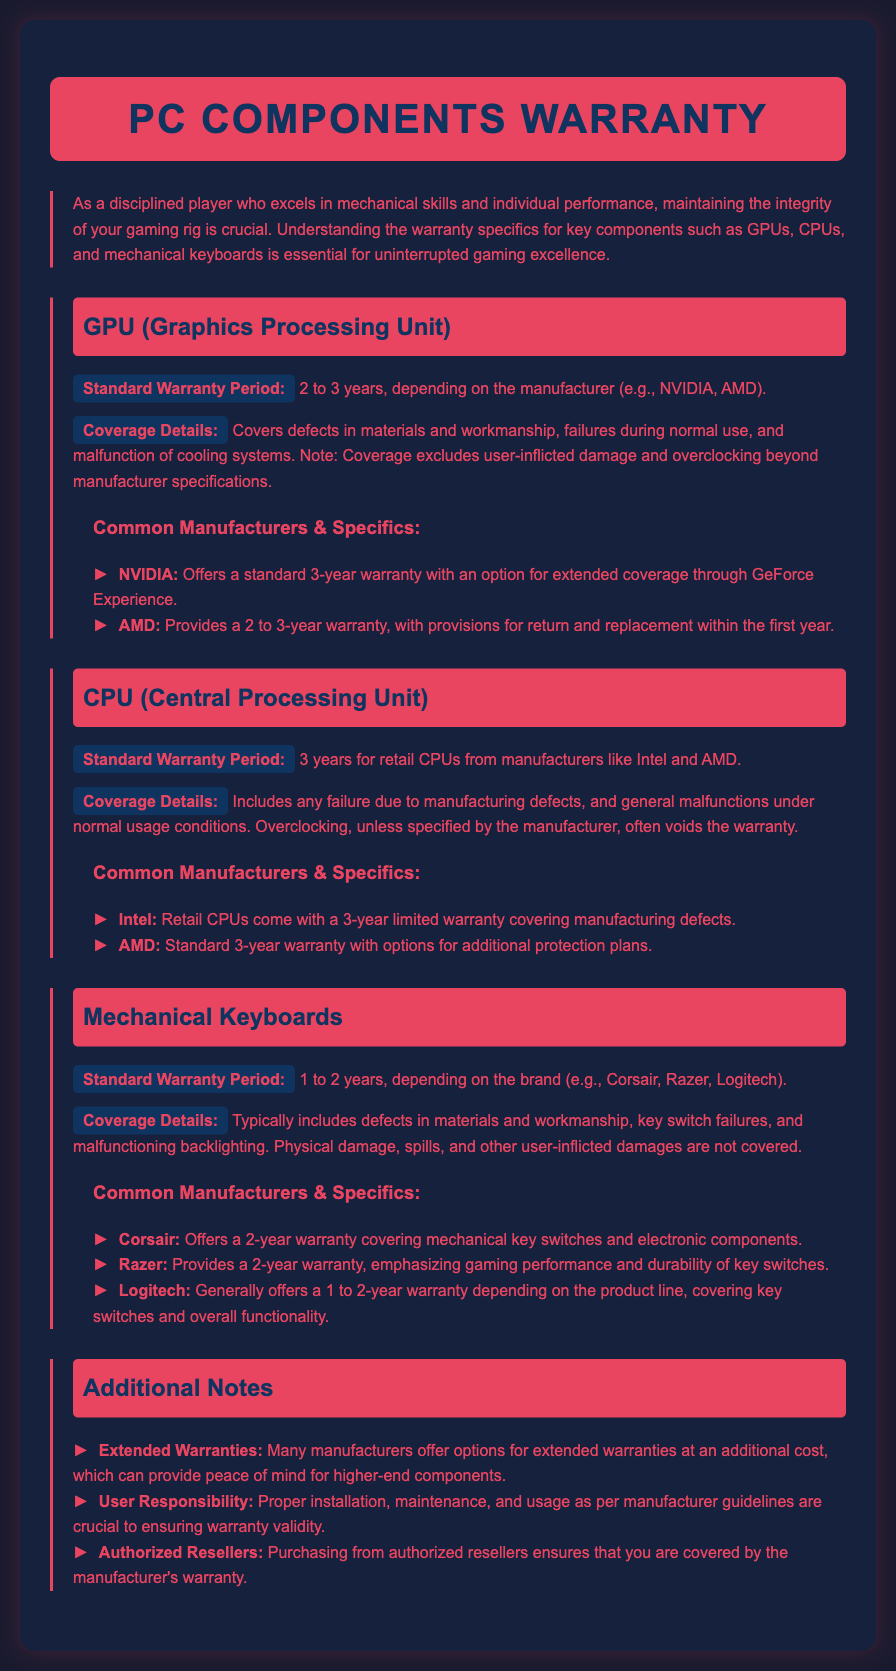What is the standard warranty period for GPUs? The document states that the standard warranty period for GPUs is 2 to 3 years, depending on the manufacturer.
Answer: 2 to 3 years What does GPU coverage exclude? The document mentions that GPU coverage excludes user-inflicted damage and overclocking beyond manufacturer specifications.
Answer: User-inflicted damage and overclocking What is the general warranty period for CPUs? It is stated in the document that retail CPUs have a standard warranty period of 3 years.
Answer: 3 years Which companies provide a 3-year warranty for CPUs? The document specifies that Intel and AMD provide a 3-year limited warranty for their retail CPUs.
Answer: Intel and AMD What is the warranty period for Corsair mechanical keyboards? The document indicates that Corsair offers a 2-year warranty for mechanical keyboards.
Answer: 2 years What type of damage is not covered under mechanical keyboards warranty? According to the document, physical damage, spills, and other user-inflicted damages are not covered.
Answer: Physical damage, spills, and user-inflicted damages How long is the warranty period for Razer keyboards? The document states that Razer provides a 2-year warranty for their keyboards.
Answer: 2 years What should users ensure to maintain warranty validity? The document highlights that proper installation, maintenance, and usage as per manufacturer guidelines are crucial for warranty validity.
Answer: Proper installation, maintenance, and usage What can provide peace of mind for higher-end components? The document notes that many manufacturers offer options for extended warranties at an additional cost.
Answer: Extended warranties 